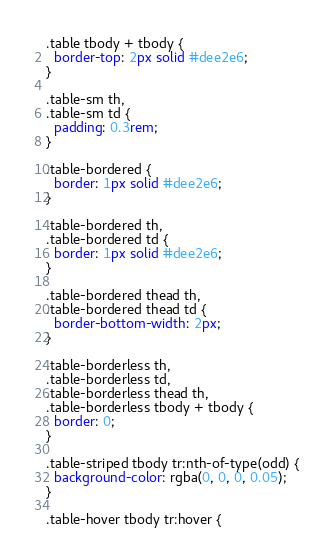Convert code to text. <code><loc_0><loc_0><loc_500><loc_500><_CSS_>
.table tbody + tbody {
  border-top: 2px solid #dee2e6;
}

.table-sm th,
.table-sm td {
  padding: 0.3rem;
}

.table-bordered {
  border: 1px solid #dee2e6;
}

.table-bordered th,
.table-bordered td {
  border: 1px solid #dee2e6;
}

.table-bordered thead th,
.table-bordered thead td {
  border-bottom-width: 2px;
}

.table-borderless th,
.table-borderless td,
.table-borderless thead th,
.table-borderless tbody + tbody {
  border: 0;
}

.table-striped tbody tr:nth-of-type(odd) {
  background-color: rgba(0, 0, 0, 0.05);
}

.table-hover tbody tr:hover {</code> 